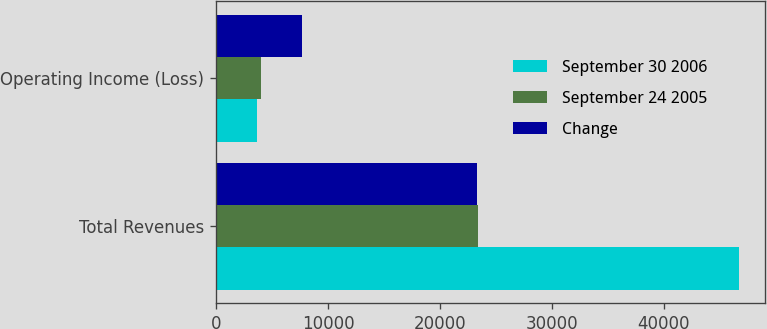<chart> <loc_0><loc_0><loc_500><loc_500><stacked_bar_chart><ecel><fcel>Total Revenues<fcel>Operating Income (Loss)<nl><fcel>September 30 2006<fcel>46723<fcel>3648<nl><fcel>September 24 2005<fcel>23414<fcel>3996<nl><fcel>Change<fcel>23309<fcel>7644<nl></chart> 